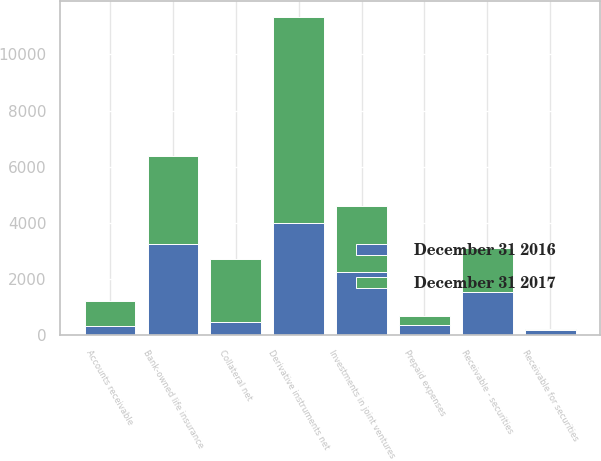Convert chart. <chart><loc_0><loc_0><loc_500><loc_500><stacked_bar_chart><ecel><fcel>Receivable - securities<fcel>Derivative instruments net<fcel>Bank-owned life insurance<fcel>Investments in joint ventures<fcel>Collateral net<fcel>Prepaid expenses<fcel>Accounts receivable<fcel>Receivable for securities<nl><fcel>December 31 2016<fcel>1561<fcel>4013<fcel>3242<fcel>2259<fcel>473<fcel>364<fcel>348<fcel>188<nl><fcel>December 31 2017<fcel>1561<fcel>7321<fcel>3158<fcel>2363<fcel>2236<fcel>333<fcel>886<fcel>40<nl></chart> 